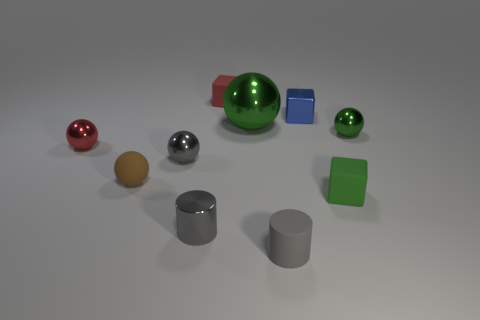There is a green metallic thing that is on the right side of the green object that is left of the small rubber cylinder; what shape is it?
Your answer should be compact. Sphere. What is the size of the metal sphere that is the same color as the big object?
Give a very brief answer. Small. Do the red thing that is right of the tiny rubber ball and the blue metallic thing have the same shape?
Offer a very short reply. Yes. Is the number of tiny rubber objects that are to the right of the green rubber object greater than the number of small gray cylinders in front of the small gray rubber object?
Ensure brevity in your answer.  No. There is a tiny green object behind the red metal object; how many small red metal spheres are behind it?
Your response must be concise. 0. There is a small block that is the same color as the large shiny object; what is it made of?
Keep it short and to the point. Rubber. What number of other objects are the same color as the tiny metal cylinder?
Provide a succinct answer. 2. The matte cube in front of the blue cube that is to the right of the tiny gray metallic sphere is what color?
Your response must be concise. Green. Are there any shiny cubes that have the same color as the small matte cylinder?
Make the answer very short. No. What number of metallic things are small things or small blue cubes?
Make the answer very short. 5. 